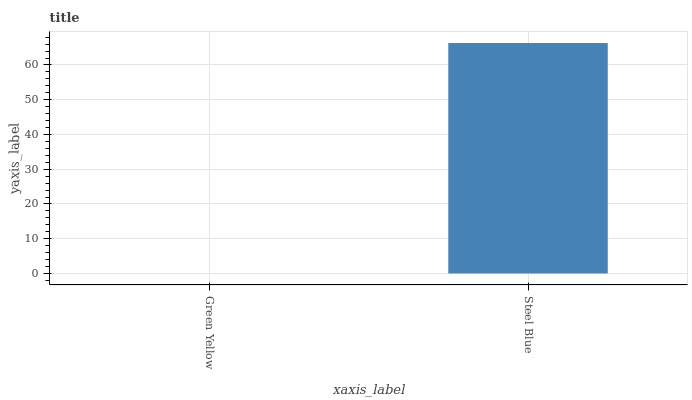Is Steel Blue the minimum?
Answer yes or no. No. Is Steel Blue greater than Green Yellow?
Answer yes or no. Yes. Is Green Yellow less than Steel Blue?
Answer yes or no. Yes. Is Green Yellow greater than Steel Blue?
Answer yes or no. No. Is Steel Blue less than Green Yellow?
Answer yes or no. No. Is Steel Blue the high median?
Answer yes or no. Yes. Is Green Yellow the low median?
Answer yes or no. Yes. Is Green Yellow the high median?
Answer yes or no. No. Is Steel Blue the low median?
Answer yes or no. No. 